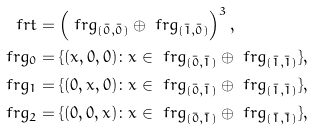<formula> <loc_0><loc_0><loc_500><loc_500>\ f r t & = \left ( \ f r g _ { ( \bar { 0 } , \bar { 0 } ) } \oplus \ f r g _ { ( \bar { 1 } , \bar { 0 } ) } \right ) ^ { 3 } , \\ \ f r g _ { 0 } & = \{ ( x , 0 , 0 ) \colon x \in \ f r g _ { ( \bar { 0 } , \bar { 1 } ) } \oplus \ f r g _ { ( \bar { 1 } , \bar { 1 } ) } \} , \\ \ f r g _ { 1 } & = \{ ( 0 , x , 0 ) \colon x \in \ f r g _ { ( \bar { 0 } , \bar { 1 } ) } \oplus \ f r g _ { ( \bar { 1 } , \bar { 1 } ) } \} , \\ \ f r g _ { 2 } & = \{ ( 0 , 0 , x ) \colon x \in \ f r g _ { ( \bar { 0 } , \bar { 1 } ) } \oplus \ f r g _ { ( \bar { 1 } , \bar { 1 } ) } \} ,</formula> 